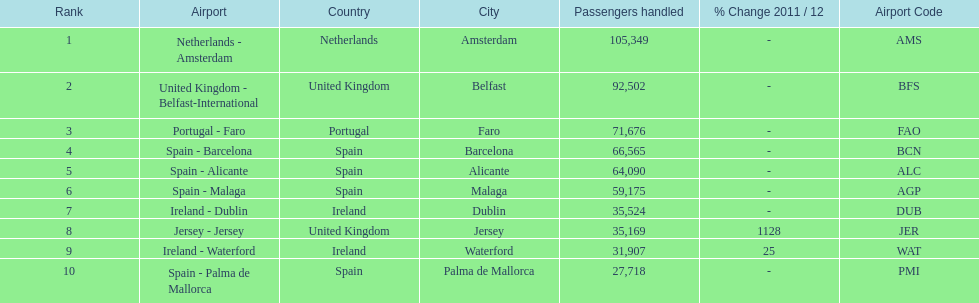How many passengers are going to or coming from spain? 217,548. 